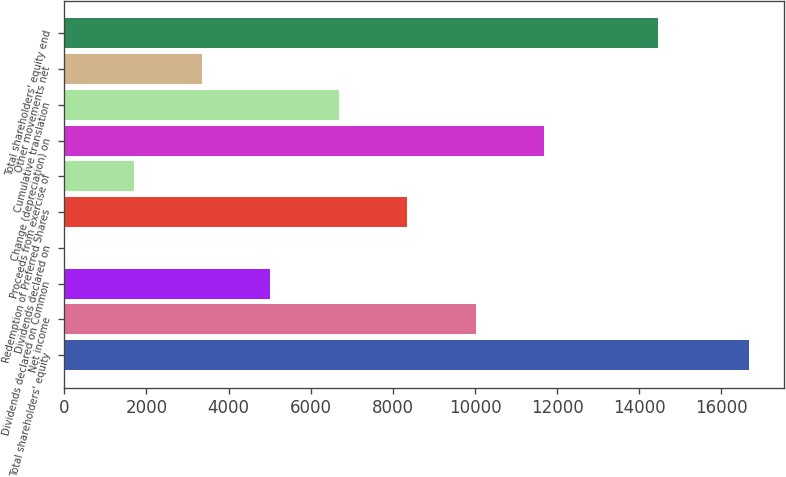Convert chart to OTSL. <chart><loc_0><loc_0><loc_500><loc_500><bar_chart><fcel>Total shareholders' equity<fcel>Net income<fcel>Dividends declared on Common<fcel>Dividends declared on<fcel>Redemption of Preferred Shares<fcel>Proceeds from exercise of<fcel>Change (depreciation) on<fcel>Cumulative translation<fcel>Other movements net<fcel>Total shareholders' equity end<nl><fcel>16677<fcel>10015.8<fcel>5019.9<fcel>24<fcel>8350.5<fcel>1689.3<fcel>11681.1<fcel>6685.2<fcel>3354.6<fcel>14446<nl></chart> 